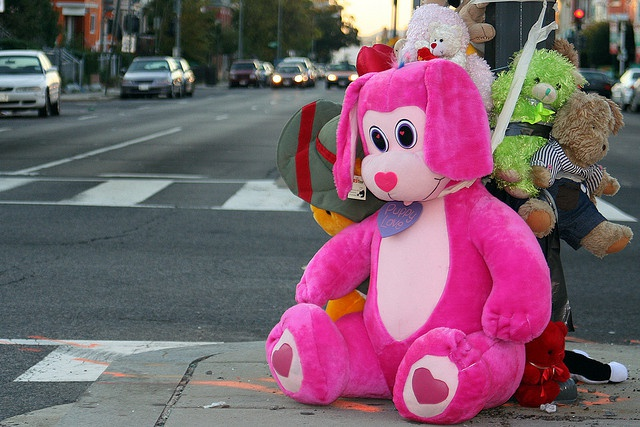Describe the objects in this image and their specific colors. I can see teddy bear in lightgray, magenta, purple, and pink tones, teddy bear in lightgray, black, gray, and maroon tones, teddy bear in lightgray, gray, maroon, and black tones, teddy bear in lightgray, olive, green, and darkgreen tones, and car in lightgray, black, darkgray, gray, and ivory tones in this image. 